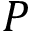Convert formula to latex. <formula><loc_0><loc_0><loc_500><loc_500>P</formula> 